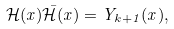Convert formula to latex. <formula><loc_0><loc_0><loc_500><loc_500>\mathcal { H } ( x ) \bar { \mathcal { H } } ( x ) = Y _ { k + 1 } ( x ) ,</formula> 